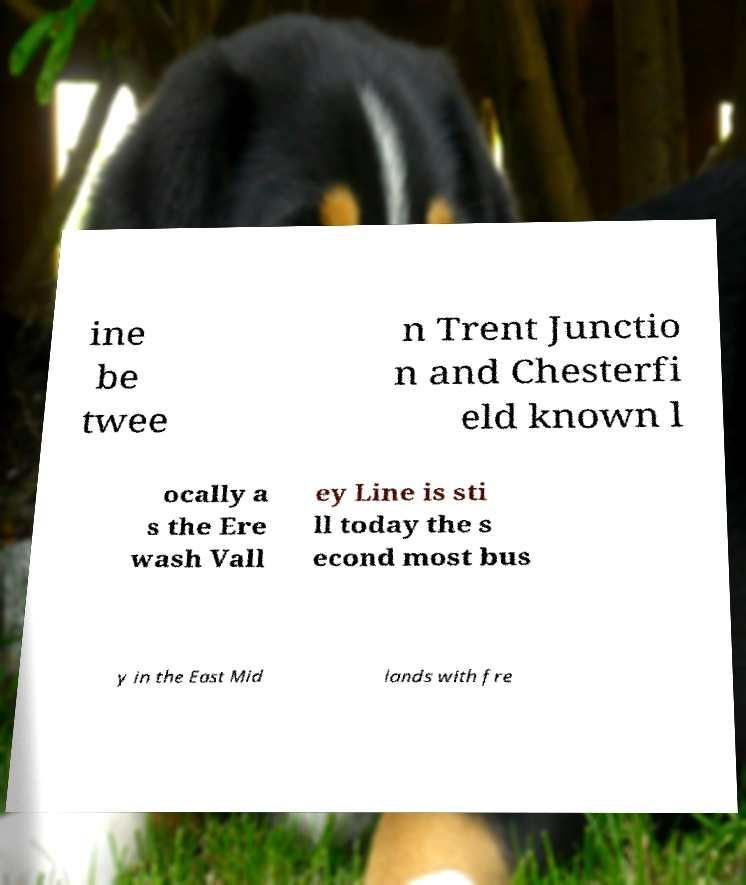There's text embedded in this image that I need extracted. Can you transcribe it verbatim? ine be twee n Trent Junctio n and Chesterfi eld known l ocally a s the Ere wash Vall ey Line is sti ll today the s econd most bus y in the East Mid lands with fre 